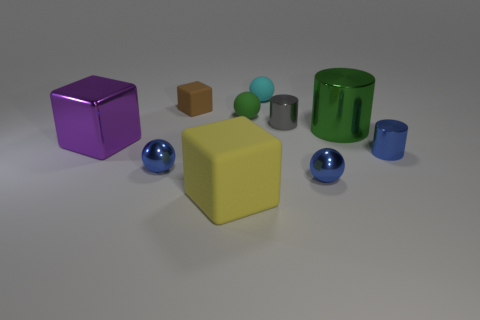The cyan thing that is made of the same material as the brown thing is what size?
Ensure brevity in your answer.  Small. What number of other rubber blocks are the same color as the small block?
Give a very brief answer. 0. Are any red cylinders visible?
Ensure brevity in your answer.  No. Does the large matte thing have the same shape as the big metal thing that is right of the big yellow matte cube?
Offer a very short reply. No. The big object that is left of the blue object that is left of the small cyan thing behind the brown rubber object is what color?
Your answer should be compact. Purple. Are there any green things on the left side of the cyan ball?
Ensure brevity in your answer.  Yes. There is a sphere that is the same color as the big cylinder; what size is it?
Your answer should be compact. Small. Is there a small cube made of the same material as the gray cylinder?
Your answer should be very brief. No. What is the color of the big metal cylinder?
Your response must be concise. Green. There is a large metallic object to the left of the cyan ball; is it the same shape as the green metal thing?
Keep it short and to the point. No. 